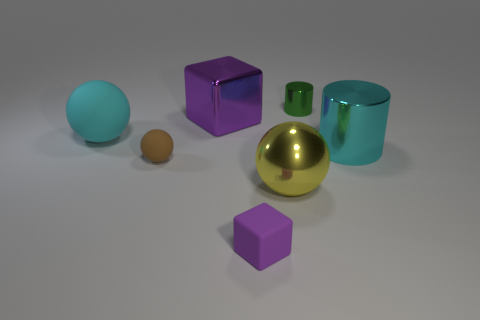What number of other things are there of the same material as the large cube
Give a very brief answer. 3. What material is the yellow thing?
Make the answer very short. Metal. There is a purple thing that is in front of the cyan rubber object; what size is it?
Ensure brevity in your answer.  Small. There is a small object behind the big cyan ball; how many cubes are to the left of it?
Your response must be concise. 2. Do the purple object behind the yellow ball and the tiny brown thing that is to the left of the large yellow metal sphere have the same shape?
Make the answer very short. No. How many cylinders are behind the big cyan metallic object and in front of the tiny green thing?
Keep it short and to the point. 0. Are there any other cubes that have the same color as the big cube?
Ensure brevity in your answer.  Yes. There is a purple shiny object that is the same size as the cyan metallic object; what shape is it?
Your answer should be very brief. Cube. Are there any matte objects to the left of the large purple object?
Ensure brevity in your answer.  Yes. Is the big cyan object left of the brown matte sphere made of the same material as the big thing behind the big cyan ball?
Keep it short and to the point. No. 